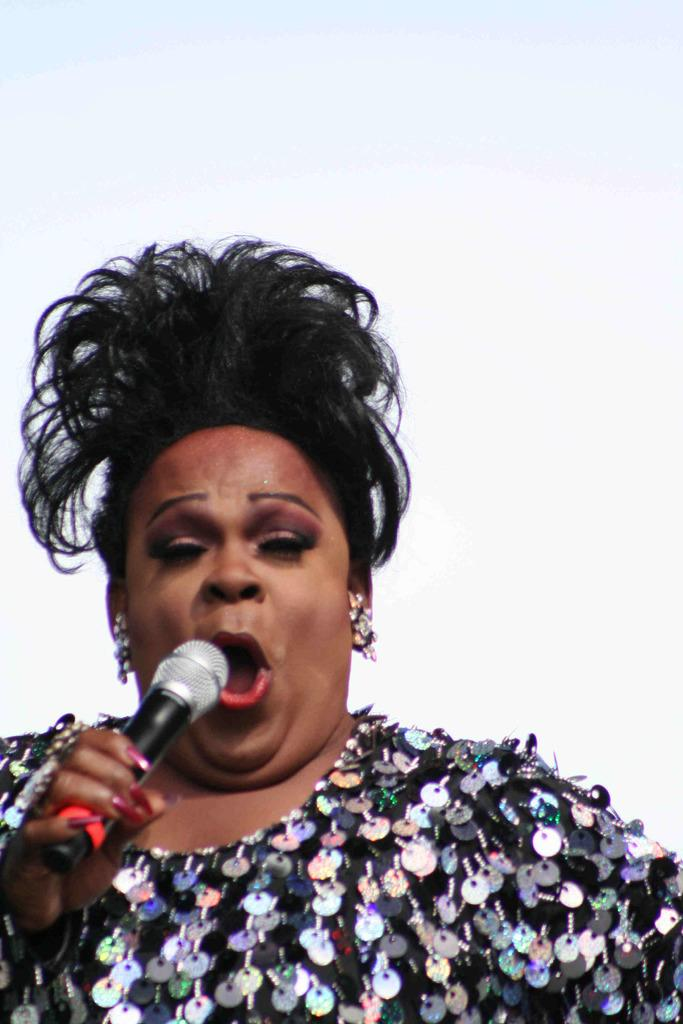Who is the main subject in the image? There is a woman in the image. What is the woman doing in the image? The woman is singing. What object is the woman holding while singing? The woman is holding a microphone. How many teeth can be seen in the image? There are no teeth visible in the image, as it features a woman singing with a microphone. 